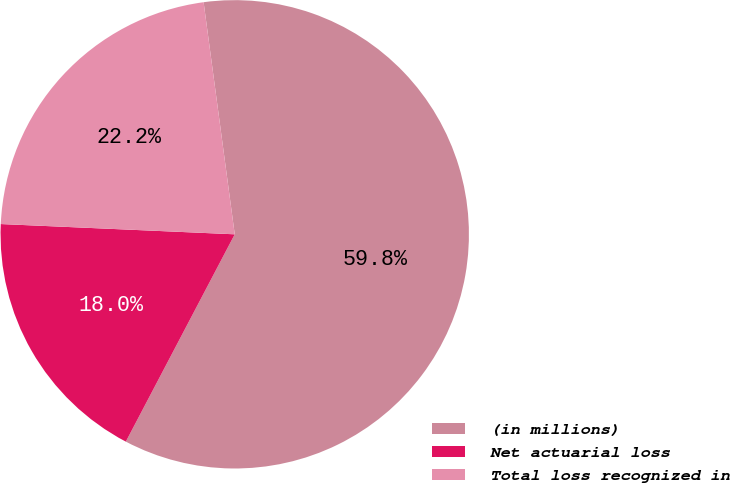Convert chart to OTSL. <chart><loc_0><loc_0><loc_500><loc_500><pie_chart><fcel>(in millions)<fcel>Net actuarial loss<fcel>Total loss recognized in<nl><fcel>59.82%<fcel>18.0%<fcel>22.18%<nl></chart> 